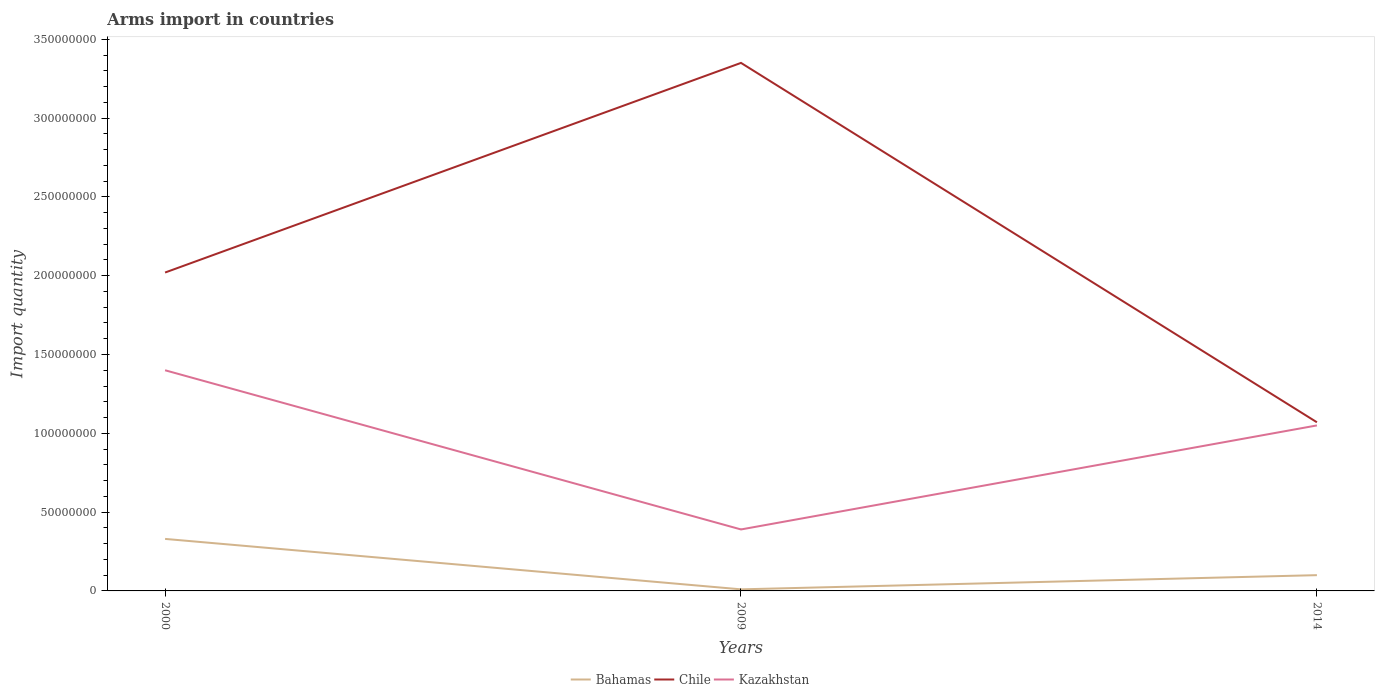Does the line corresponding to Kazakhstan intersect with the line corresponding to Chile?
Provide a succinct answer. No. Across all years, what is the maximum total arms import in Kazakhstan?
Offer a terse response. 3.90e+07. What is the total total arms import in Bahamas in the graph?
Ensure brevity in your answer.  3.20e+07. What is the difference between the highest and the second highest total arms import in Chile?
Provide a succinct answer. 2.28e+08. What is the difference between the highest and the lowest total arms import in Bahamas?
Keep it short and to the point. 1. Is the total arms import in Chile strictly greater than the total arms import in Bahamas over the years?
Your response must be concise. No. How many lines are there?
Your response must be concise. 3. How many years are there in the graph?
Make the answer very short. 3. What is the difference between two consecutive major ticks on the Y-axis?
Give a very brief answer. 5.00e+07. Are the values on the major ticks of Y-axis written in scientific E-notation?
Offer a very short reply. No. Does the graph contain grids?
Offer a terse response. No. How are the legend labels stacked?
Your response must be concise. Horizontal. What is the title of the graph?
Make the answer very short. Arms import in countries. Does "Channel Islands" appear as one of the legend labels in the graph?
Your answer should be compact. No. What is the label or title of the Y-axis?
Provide a succinct answer. Import quantity. What is the Import quantity of Bahamas in 2000?
Ensure brevity in your answer.  3.30e+07. What is the Import quantity in Chile in 2000?
Your response must be concise. 2.02e+08. What is the Import quantity of Kazakhstan in 2000?
Provide a short and direct response. 1.40e+08. What is the Import quantity of Bahamas in 2009?
Provide a succinct answer. 1.00e+06. What is the Import quantity in Chile in 2009?
Offer a terse response. 3.35e+08. What is the Import quantity in Kazakhstan in 2009?
Ensure brevity in your answer.  3.90e+07. What is the Import quantity of Bahamas in 2014?
Make the answer very short. 1.00e+07. What is the Import quantity of Chile in 2014?
Keep it short and to the point. 1.07e+08. What is the Import quantity of Kazakhstan in 2014?
Offer a terse response. 1.05e+08. Across all years, what is the maximum Import quantity in Bahamas?
Offer a very short reply. 3.30e+07. Across all years, what is the maximum Import quantity in Chile?
Give a very brief answer. 3.35e+08. Across all years, what is the maximum Import quantity of Kazakhstan?
Your response must be concise. 1.40e+08. Across all years, what is the minimum Import quantity of Bahamas?
Give a very brief answer. 1.00e+06. Across all years, what is the minimum Import quantity of Chile?
Your answer should be compact. 1.07e+08. Across all years, what is the minimum Import quantity of Kazakhstan?
Ensure brevity in your answer.  3.90e+07. What is the total Import quantity in Bahamas in the graph?
Ensure brevity in your answer.  4.40e+07. What is the total Import quantity in Chile in the graph?
Your answer should be compact. 6.44e+08. What is the total Import quantity of Kazakhstan in the graph?
Your answer should be very brief. 2.84e+08. What is the difference between the Import quantity in Bahamas in 2000 and that in 2009?
Your answer should be compact. 3.20e+07. What is the difference between the Import quantity in Chile in 2000 and that in 2009?
Ensure brevity in your answer.  -1.33e+08. What is the difference between the Import quantity of Kazakhstan in 2000 and that in 2009?
Give a very brief answer. 1.01e+08. What is the difference between the Import quantity of Bahamas in 2000 and that in 2014?
Give a very brief answer. 2.30e+07. What is the difference between the Import quantity in Chile in 2000 and that in 2014?
Keep it short and to the point. 9.50e+07. What is the difference between the Import quantity of Kazakhstan in 2000 and that in 2014?
Provide a short and direct response. 3.50e+07. What is the difference between the Import quantity of Bahamas in 2009 and that in 2014?
Keep it short and to the point. -9.00e+06. What is the difference between the Import quantity in Chile in 2009 and that in 2014?
Give a very brief answer. 2.28e+08. What is the difference between the Import quantity in Kazakhstan in 2009 and that in 2014?
Your answer should be very brief. -6.60e+07. What is the difference between the Import quantity of Bahamas in 2000 and the Import quantity of Chile in 2009?
Keep it short and to the point. -3.02e+08. What is the difference between the Import quantity in Bahamas in 2000 and the Import quantity in Kazakhstan in 2009?
Ensure brevity in your answer.  -6.00e+06. What is the difference between the Import quantity in Chile in 2000 and the Import quantity in Kazakhstan in 2009?
Ensure brevity in your answer.  1.63e+08. What is the difference between the Import quantity of Bahamas in 2000 and the Import quantity of Chile in 2014?
Provide a succinct answer. -7.40e+07. What is the difference between the Import quantity of Bahamas in 2000 and the Import quantity of Kazakhstan in 2014?
Your answer should be compact. -7.20e+07. What is the difference between the Import quantity of Chile in 2000 and the Import quantity of Kazakhstan in 2014?
Provide a short and direct response. 9.70e+07. What is the difference between the Import quantity of Bahamas in 2009 and the Import quantity of Chile in 2014?
Your response must be concise. -1.06e+08. What is the difference between the Import quantity in Bahamas in 2009 and the Import quantity in Kazakhstan in 2014?
Your answer should be compact. -1.04e+08. What is the difference between the Import quantity in Chile in 2009 and the Import quantity in Kazakhstan in 2014?
Your answer should be very brief. 2.30e+08. What is the average Import quantity of Bahamas per year?
Your answer should be compact. 1.47e+07. What is the average Import quantity in Chile per year?
Your answer should be compact. 2.15e+08. What is the average Import quantity in Kazakhstan per year?
Provide a succinct answer. 9.47e+07. In the year 2000, what is the difference between the Import quantity in Bahamas and Import quantity in Chile?
Ensure brevity in your answer.  -1.69e+08. In the year 2000, what is the difference between the Import quantity in Bahamas and Import quantity in Kazakhstan?
Provide a succinct answer. -1.07e+08. In the year 2000, what is the difference between the Import quantity in Chile and Import quantity in Kazakhstan?
Make the answer very short. 6.20e+07. In the year 2009, what is the difference between the Import quantity in Bahamas and Import quantity in Chile?
Give a very brief answer. -3.34e+08. In the year 2009, what is the difference between the Import quantity in Bahamas and Import quantity in Kazakhstan?
Offer a very short reply. -3.80e+07. In the year 2009, what is the difference between the Import quantity in Chile and Import quantity in Kazakhstan?
Your answer should be compact. 2.96e+08. In the year 2014, what is the difference between the Import quantity of Bahamas and Import quantity of Chile?
Your answer should be very brief. -9.70e+07. In the year 2014, what is the difference between the Import quantity in Bahamas and Import quantity in Kazakhstan?
Ensure brevity in your answer.  -9.50e+07. In the year 2014, what is the difference between the Import quantity in Chile and Import quantity in Kazakhstan?
Make the answer very short. 2.00e+06. What is the ratio of the Import quantity of Chile in 2000 to that in 2009?
Your response must be concise. 0.6. What is the ratio of the Import quantity of Kazakhstan in 2000 to that in 2009?
Your answer should be compact. 3.59. What is the ratio of the Import quantity in Chile in 2000 to that in 2014?
Provide a succinct answer. 1.89. What is the ratio of the Import quantity in Bahamas in 2009 to that in 2014?
Offer a terse response. 0.1. What is the ratio of the Import quantity of Chile in 2009 to that in 2014?
Keep it short and to the point. 3.13. What is the ratio of the Import quantity in Kazakhstan in 2009 to that in 2014?
Provide a succinct answer. 0.37. What is the difference between the highest and the second highest Import quantity in Bahamas?
Ensure brevity in your answer.  2.30e+07. What is the difference between the highest and the second highest Import quantity in Chile?
Your answer should be very brief. 1.33e+08. What is the difference between the highest and the second highest Import quantity in Kazakhstan?
Provide a short and direct response. 3.50e+07. What is the difference between the highest and the lowest Import quantity of Bahamas?
Your answer should be compact. 3.20e+07. What is the difference between the highest and the lowest Import quantity in Chile?
Offer a very short reply. 2.28e+08. What is the difference between the highest and the lowest Import quantity in Kazakhstan?
Give a very brief answer. 1.01e+08. 